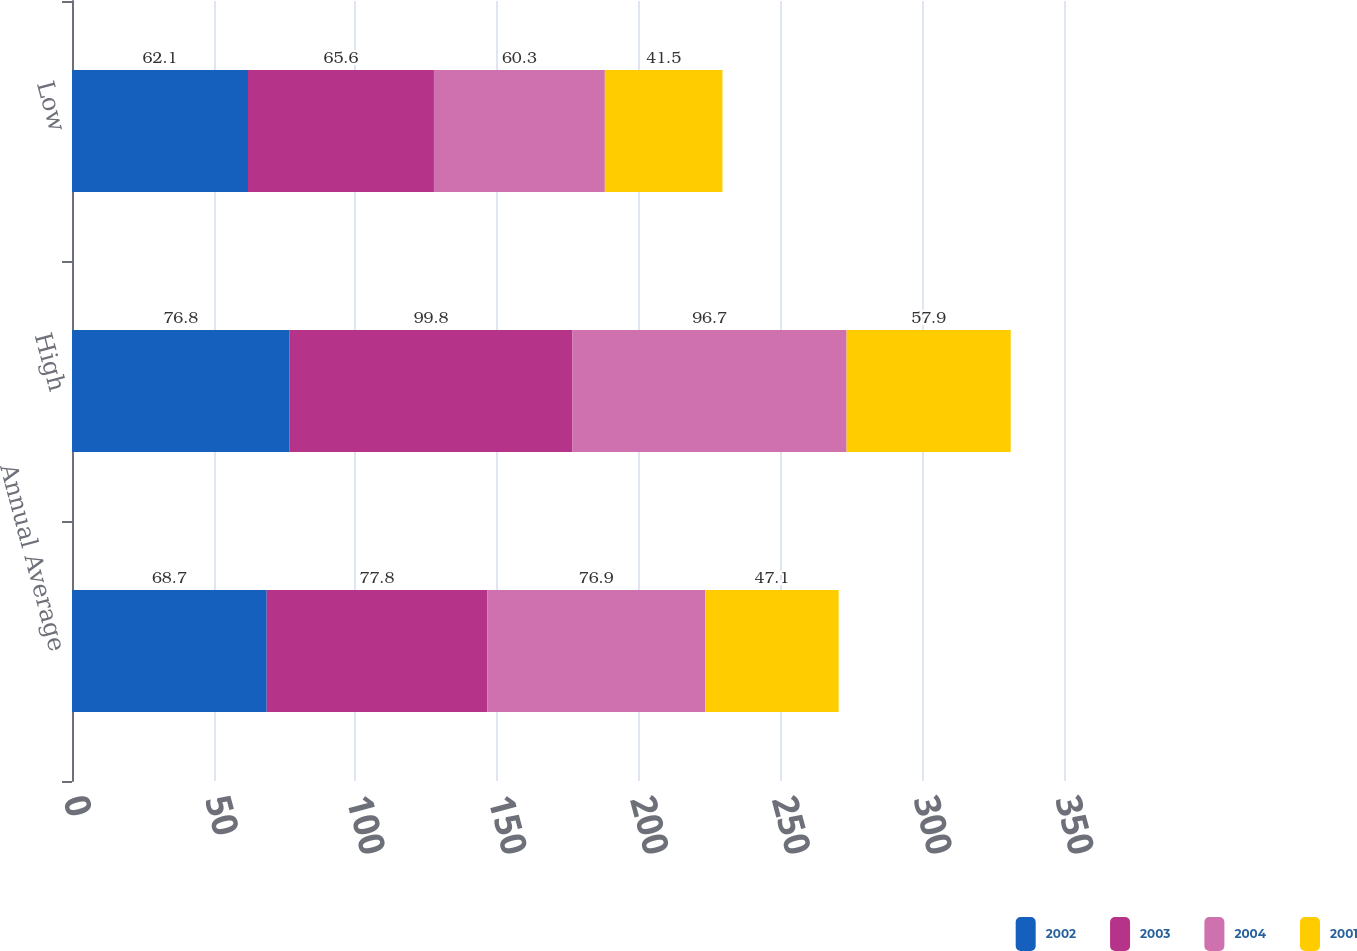<chart> <loc_0><loc_0><loc_500><loc_500><stacked_bar_chart><ecel><fcel>Annual Average<fcel>High<fcel>Low<nl><fcel>2002<fcel>68.7<fcel>76.8<fcel>62.1<nl><fcel>2003<fcel>77.8<fcel>99.8<fcel>65.6<nl><fcel>2004<fcel>76.9<fcel>96.7<fcel>60.3<nl><fcel>2001<fcel>47.1<fcel>57.9<fcel>41.5<nl></chart> 